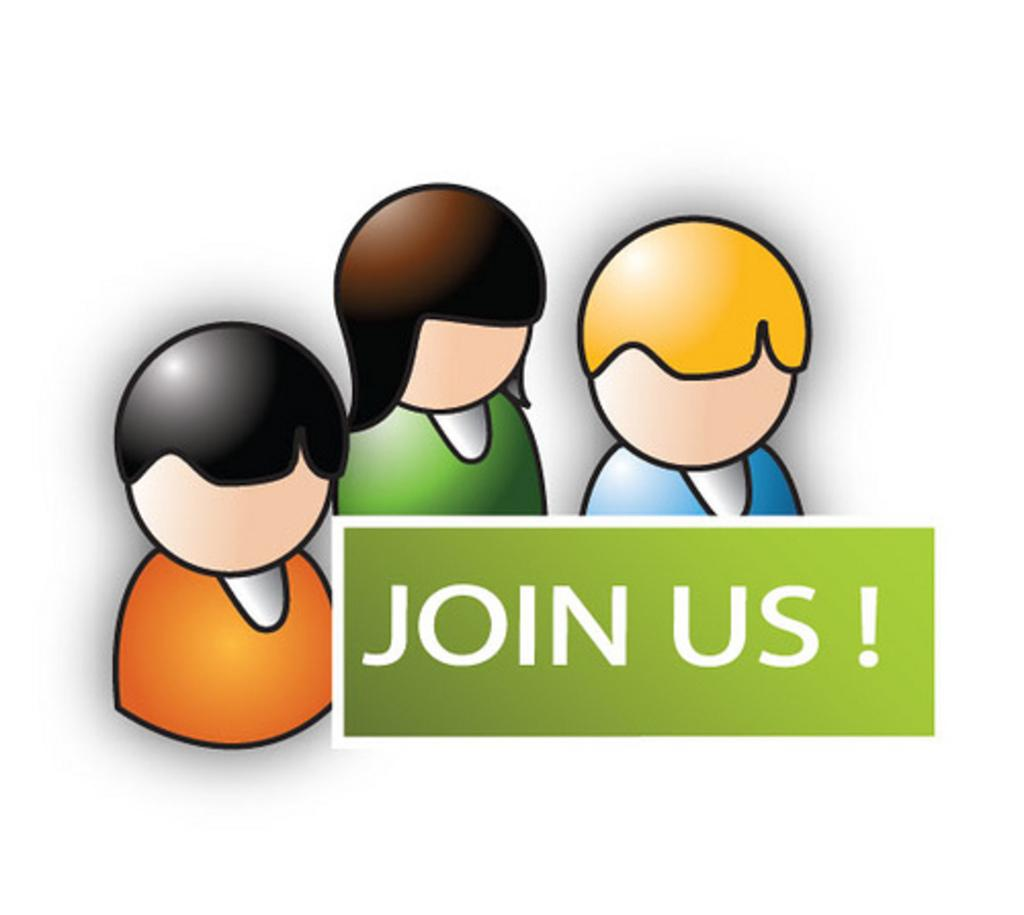What can be found on the image? There is text on the image. How much did the rod increase in the image? There is no rod present in the image, so it is not possible to determine any increase. 